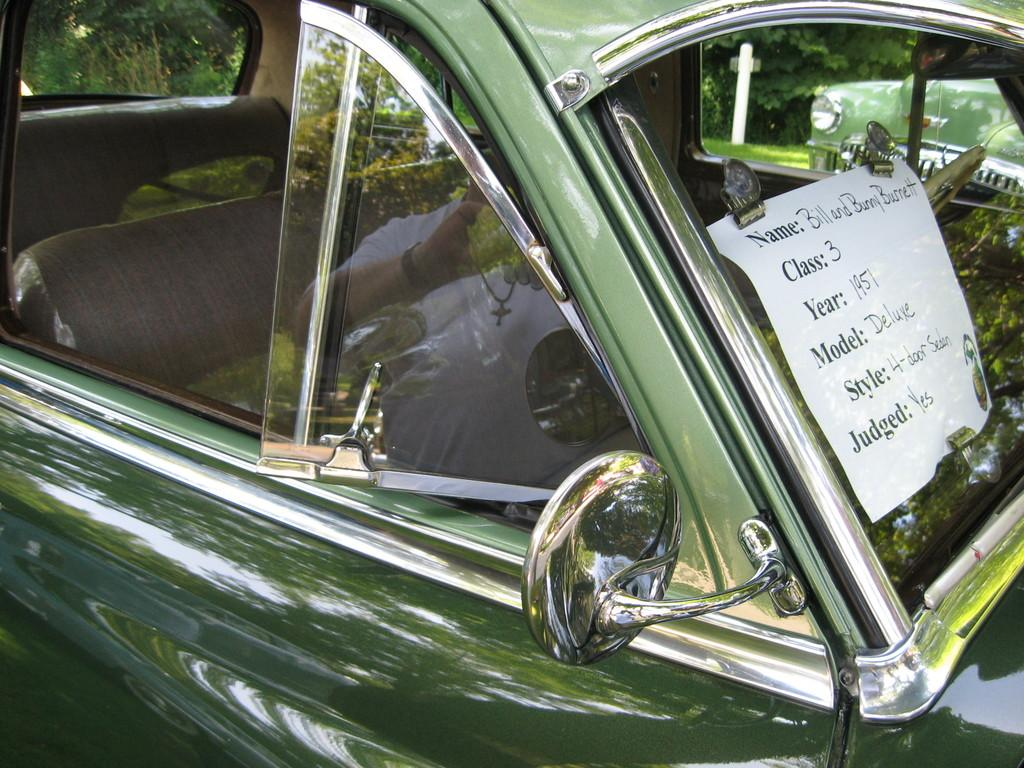What is the main subject of the image? The main subject of the image is a car. Can you describe the car's appearance? The car is green and has windows. What additional feature can be seen on the car? The car has a mirror. What is present on the right side of the car? There is a paper on the right side of the car. What type of property does the car owner have in the image? There is no information about the car owner's property in the image. How long will the car's voyage take in the image? The image does not depict the car in motion, so there is no information about a voyage. 